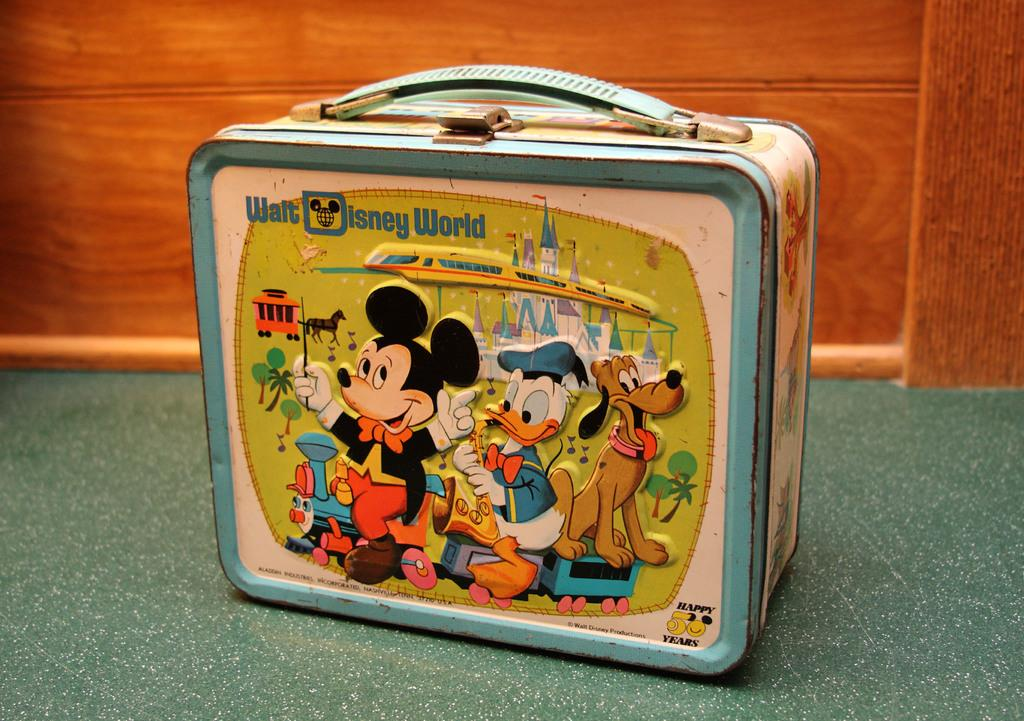What is the main object in the image? There is a box in the image. What can be seen on the box? The box has cartoon pictures on it. What colors are used for the cartoon pictures? The cartoon pictures are in blue, white, and green colors. What type of surface is visible in the background of the image? There is a wooden surface in the background of the image. Can you tell me how many crooks are hiding behind the box in the image? There are no crooks present in the image; it only features a box with cartoon pictures on it. What type of plantation can be seen in the background of the image? There is no plantation visible in the image; it only features a wooden surface in the background. 